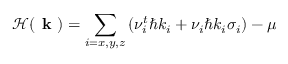Convert formula to latex. <formula><loc_0><loc_0><loc_500><loc_500>\mathcal { H } ( k ) = \sum _ { i = x , y , z } \left ( \nu _ { i } ^ { t } \hbar { k } _ { i } + \nu _ { i } \hbar { k } _ { i } \sigma _ { i } \right ) - \mu</formula> 